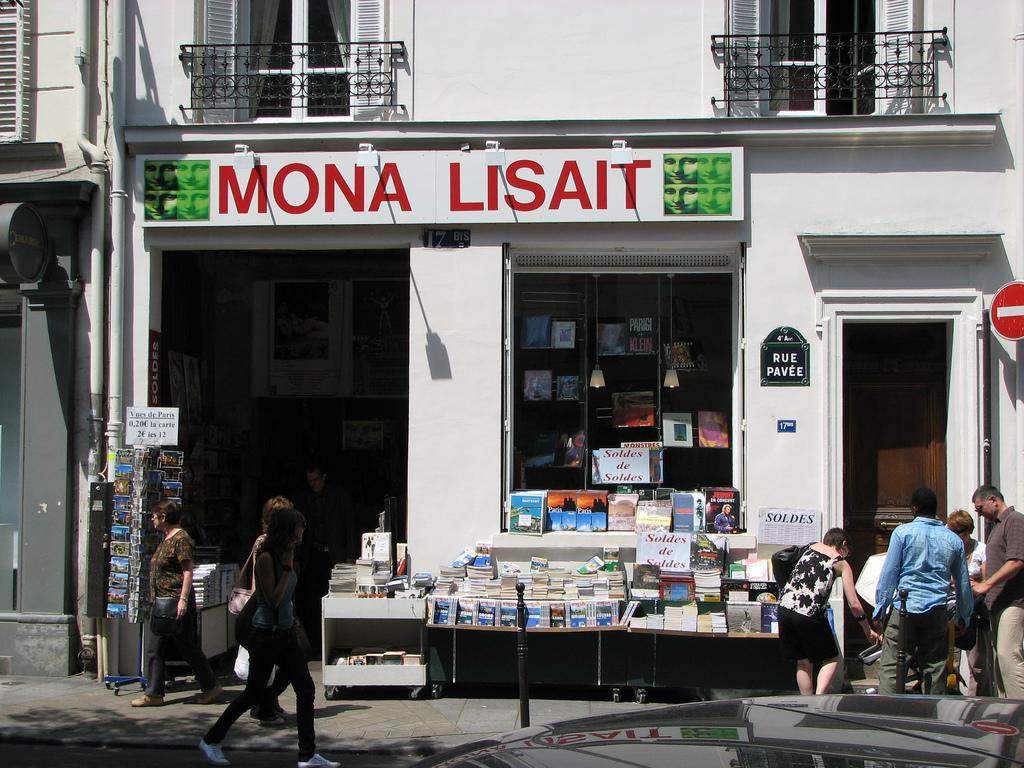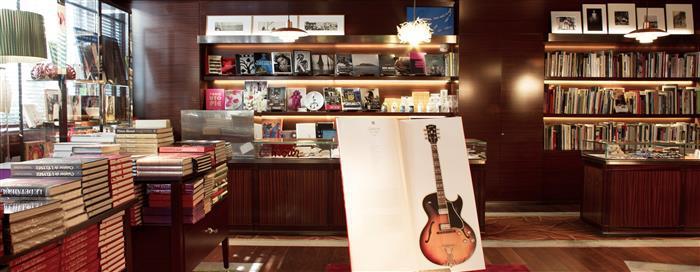The first image is the image on the left, the second image is the image on the right. Examine the images to the left and right. Is the description "There are two bookstore storefronts." accurate? Answer yes or no. No. 